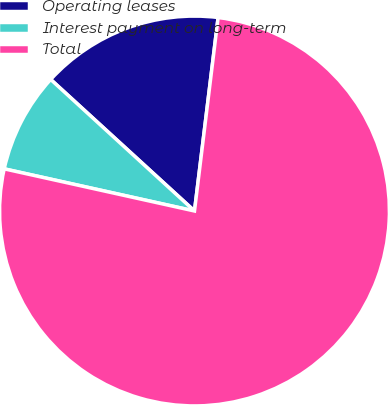<chart> <loc_0><loc_0><loc_500><loc_500><pie_chart><fcel>Operating leases<fcel>Interest payment on long-term<fcel>Total<nl><fcel>15.14%<fcel>8.32%<fcel>76.53%<nl></chart> 